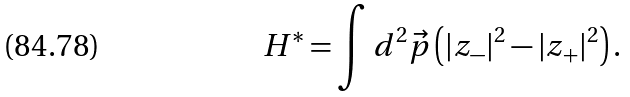<formula> <loc_0><loc_0><loc_500><loc_500>H ^ { * } = \int d ^ { 2 } \vec { p } \left ( | z _ { - } | ^ { 2 } - | z _ { + } | ^ { 2 } \right ) .</formula> 